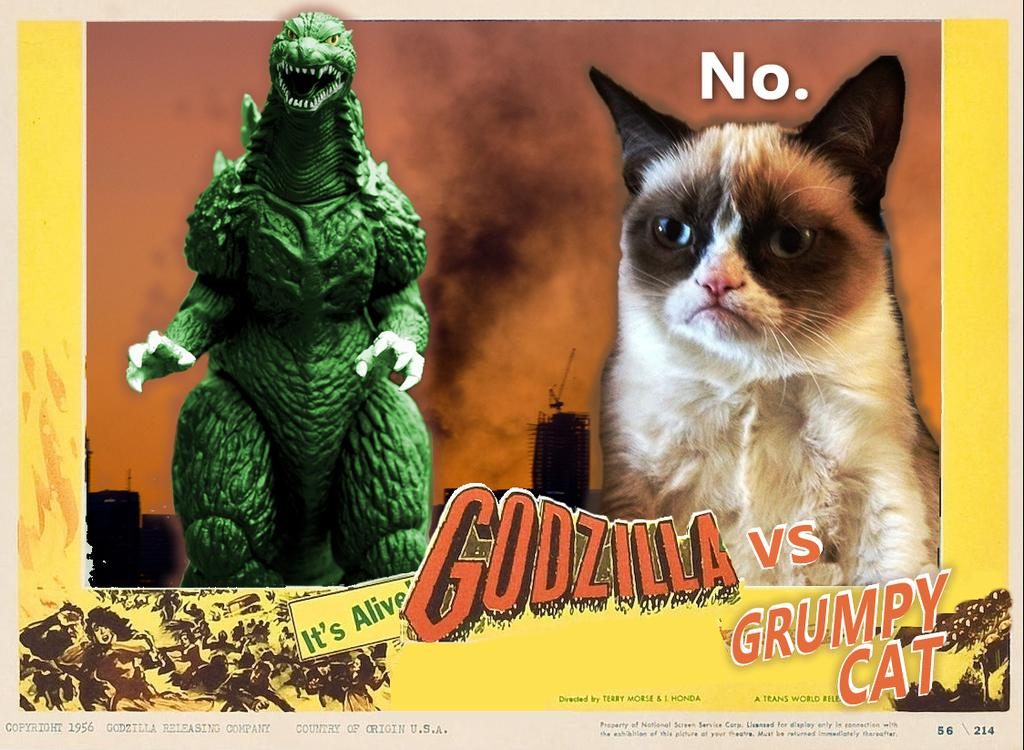What type of visual is depicted in the image? The image is a poster. What animal is featured in the poster? There is a cat in the image. What fictional character is also present in the poster? There is a representation of Godzilla in the image. What can be found on the poster besides images? There is text on the poster. Are there any additional elements at the bottom of the poster? There are figures at the bottom of the poster. What type of whip is being used by the cat in the image? There is no whip present in the image; it features a cat and Godzilla along with text and figures. 